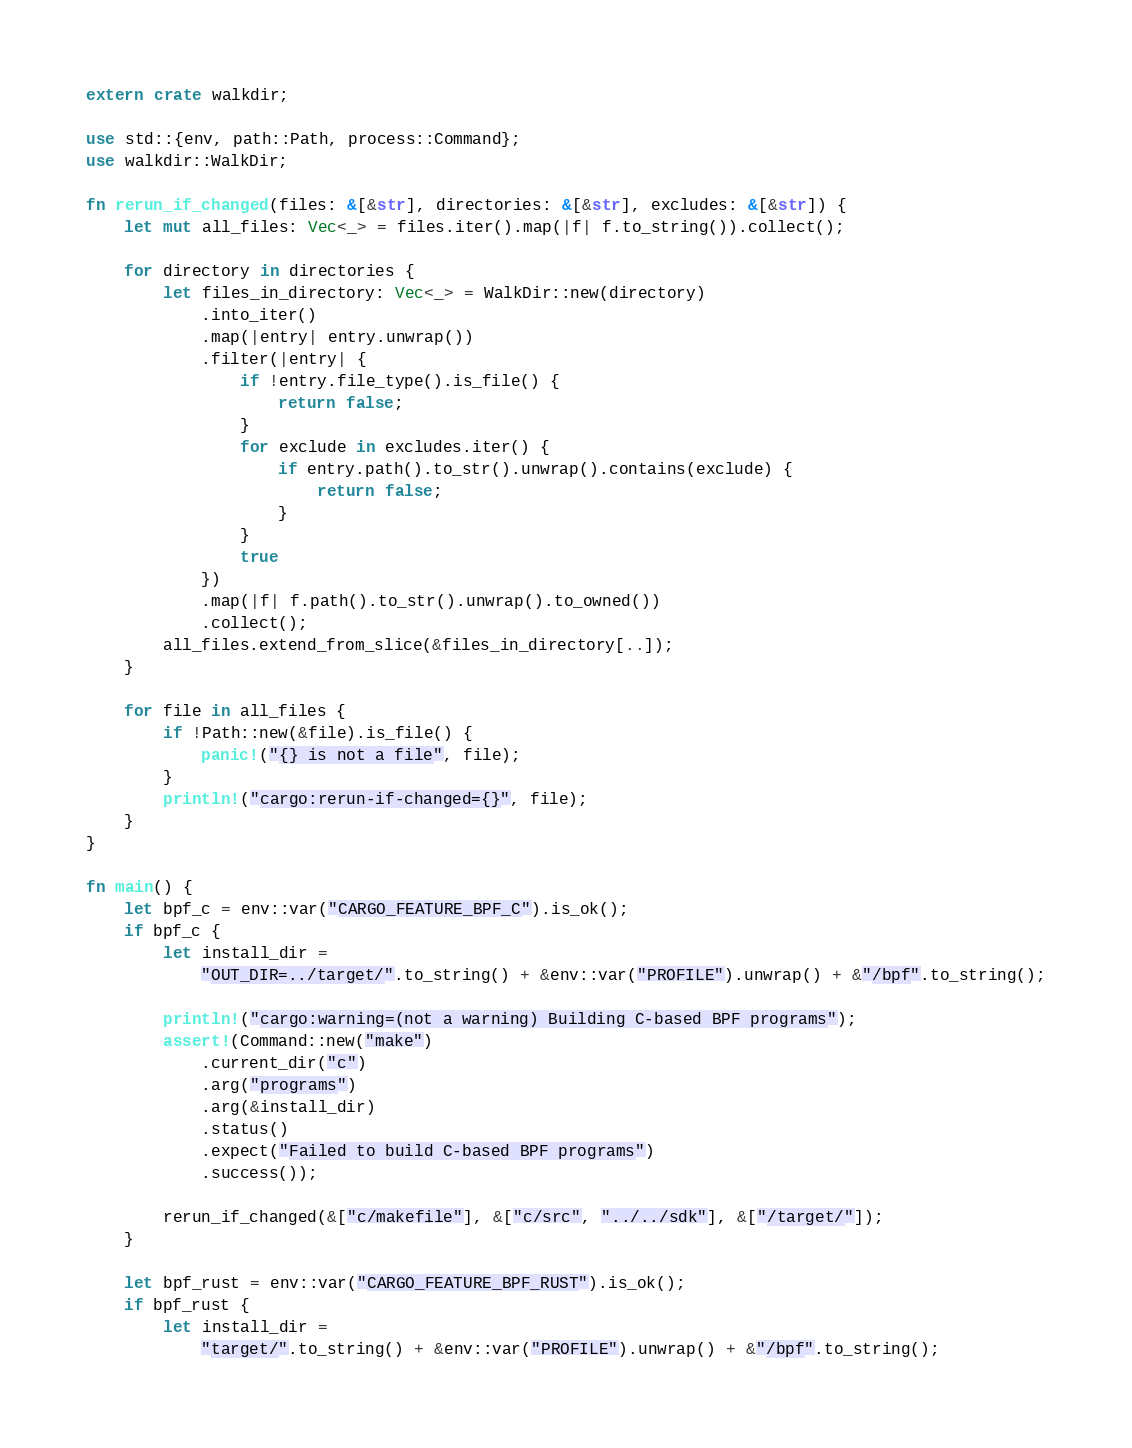Convert code to text. <code><loc_0><loc_0><loc_500><loc_500><_Rust_>extern crate walkdir;

use std::{env, path::Path, process::Command};
use walkdir::WalkDir;

fn rerun_if_changed(files: &[&str], directories: &[&str], excludes: &[&str]) {
    let mut all_files: Vec<_> = files.iter().map(|f| f.to_string()).collect();

    for directory in directories {
        let files_in_directory: Vec<_> = WalkDir::new(directory)
            .into_iter()
            .map(|entry| entry.unwrap())
            .filter(|entry| {
                if !entry.file_type().is_file() {
                    return false;
                }
                for exclude in excludes.iter() {
                    if entry.path().to_str().unwrap().contains(exclude) {
                        return false;
                    }
                }
                true
            })
            .map(|f| f.path().to_str().unwrap().to_owned())
            .collect();
        all_files.extend_from_slice(&files_in_directory[..]);
    }

    for file in all_files {
        if !Path::new(&file).is_file() {
            panic!("{} is not a file", file);
        }
        println!("cargo:rerun-if-changed={}", file);
    }
}

fn main() {
    let bpf_c = env::var("CARGO_FEATURE_BPF_C").is_ok();
    if bpf_c {
        let install_dir =
            "OUT_DIR=../target/".to_string() + &env::var("PROFILE").unwrap() + &"/bpf".to_string();

        println!("cargo:warning=(not a warning) Building C-based BPF programs");
        assert!(Command::new("make")
            .current_dir("c")
            .arg("programs")
            .arg(&install_dir)
            .status()
            .expect("Failed to build C-based BPF programs")
            .success());

        rerun_if_changed(&["c/makefile"], &["c/src", "../../sdk"], &["/target/"]);
    }

    let bpf_rust = env::var("CARGO_FEATURE_BPF_RUST").is_ok();
    if bpf_rust {
        let install_dir =
            "target/".to_string() + &env::var("PROFILE").unwrap() + &"/bpf".to_string();
</code> 